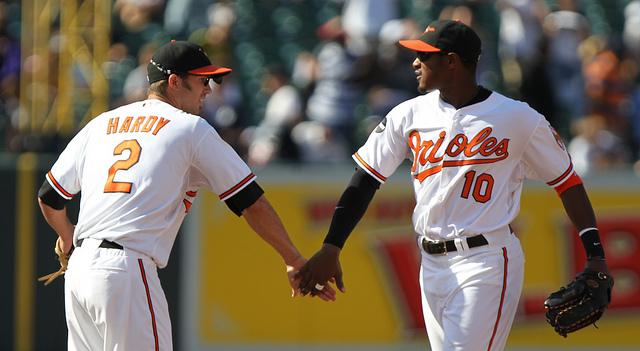What color are their hats?
Short answer required. Black. Do the both have numbers on their shirts?
Keep it brief. Yes. Are they shaking hands?
Concise answer only. No. 